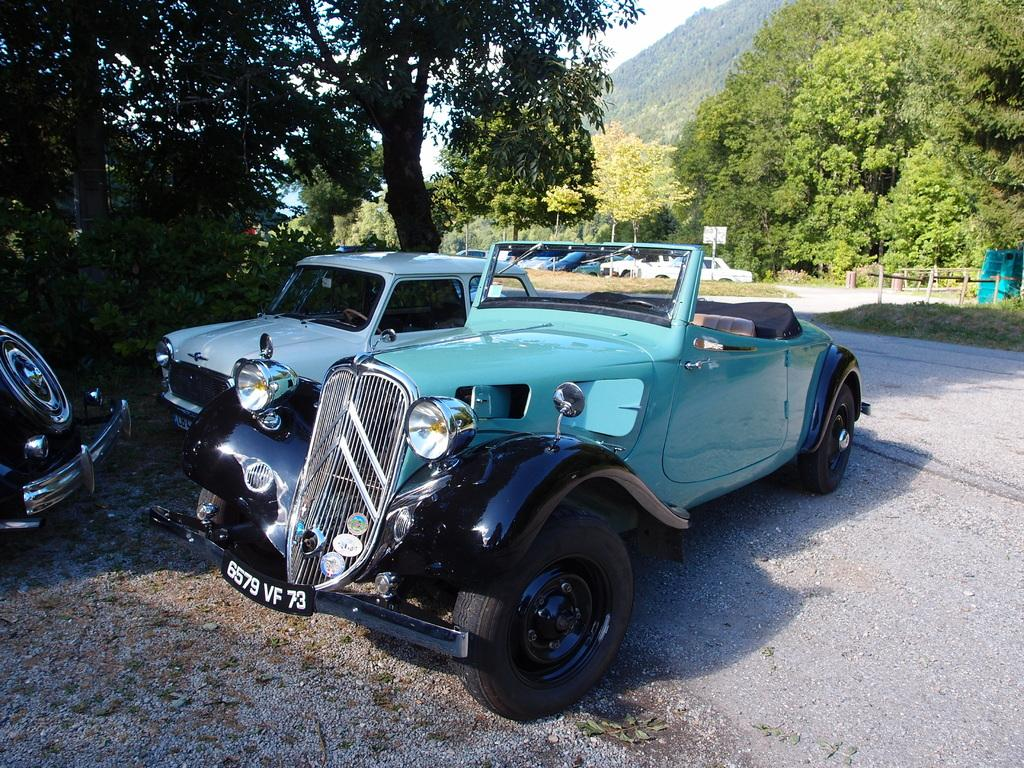How many cars can be seen on the road in the image? There are three cars on the road in the image. What can be seen in the background of the image? There are trees in the background of the image. What is visible above the cars and trees in the image? The sky is visible in the image. How many socks are hanging on the clothesline in the image? There are no socks or clotheslines present in the image. 